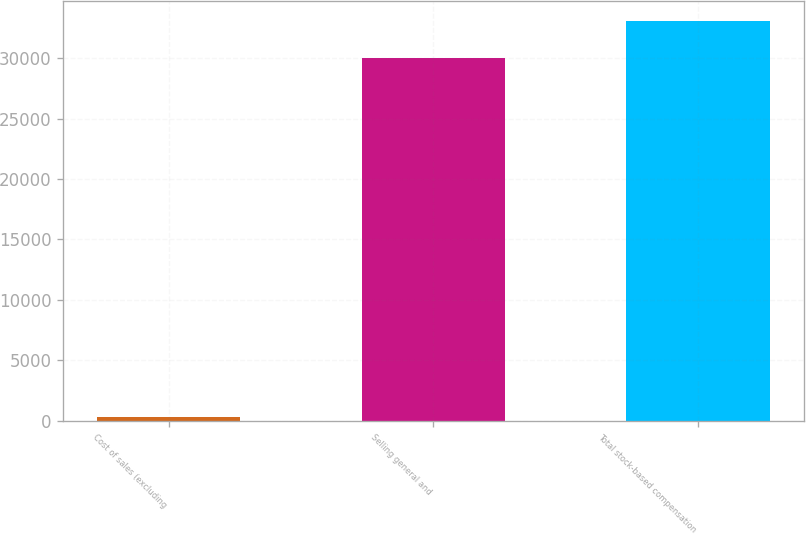Convert chart. <chart><loc_0><loc_0><loc_500><loc_500><bar_chart><fcel>Cost of sales (excluding<fcel>Selling general and<fcel>Total stock-based compensation<nl><fcel>293<fcel>30061<fcel>33067.1<nl></chart> 